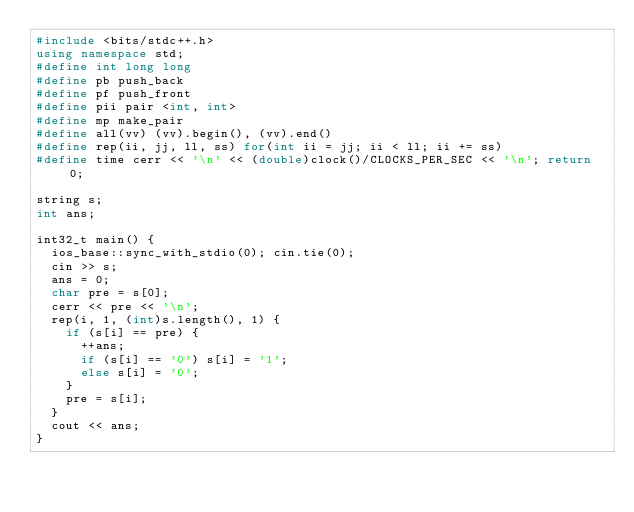<code> <loc_0><loc_0><loc_500><loc_500><_C++_>#include <bits/stdc++.h>
using namespace std;
#define int long long
#define pb push_back
#define pf push_front
#define pii pair <int, int>
#define mp make_pair
#define all(vv) (vv).begin(), (vv).end()
#define rep(ii, jj, ll, ss) for(int ii = jj; ii < ll; ii += ss)
#define time cerr << '\n' << (double)clock()/CLOCKS_PER_SEC << '\n'; return 0;

string s;
int ans;

int32_t main() {
	ios_base::sync_with_stdio(0); cin.tie(0);
	cin >> s;
	ans = 0;
	char pre = s[0];
	cerr << pre << '\n';
	rep(i, 1, (int)s.length(), 1) {
		if (s[i] == pre) {
			++ans;
			if (s[i] == '0') s[i] = '1';
			else s[i] = '0';
		}
		pre = s[i];
	}
	cout << ans;
}</code> 